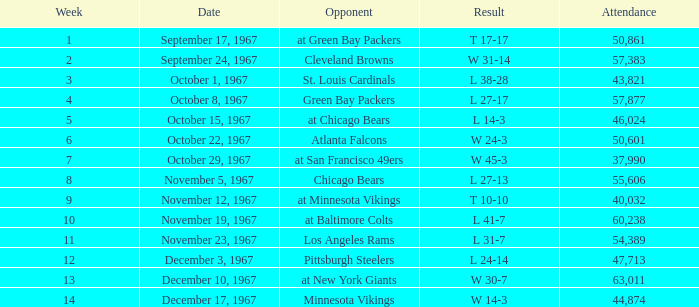In how many weeks does the result amount to t 10-10? 1.0. 